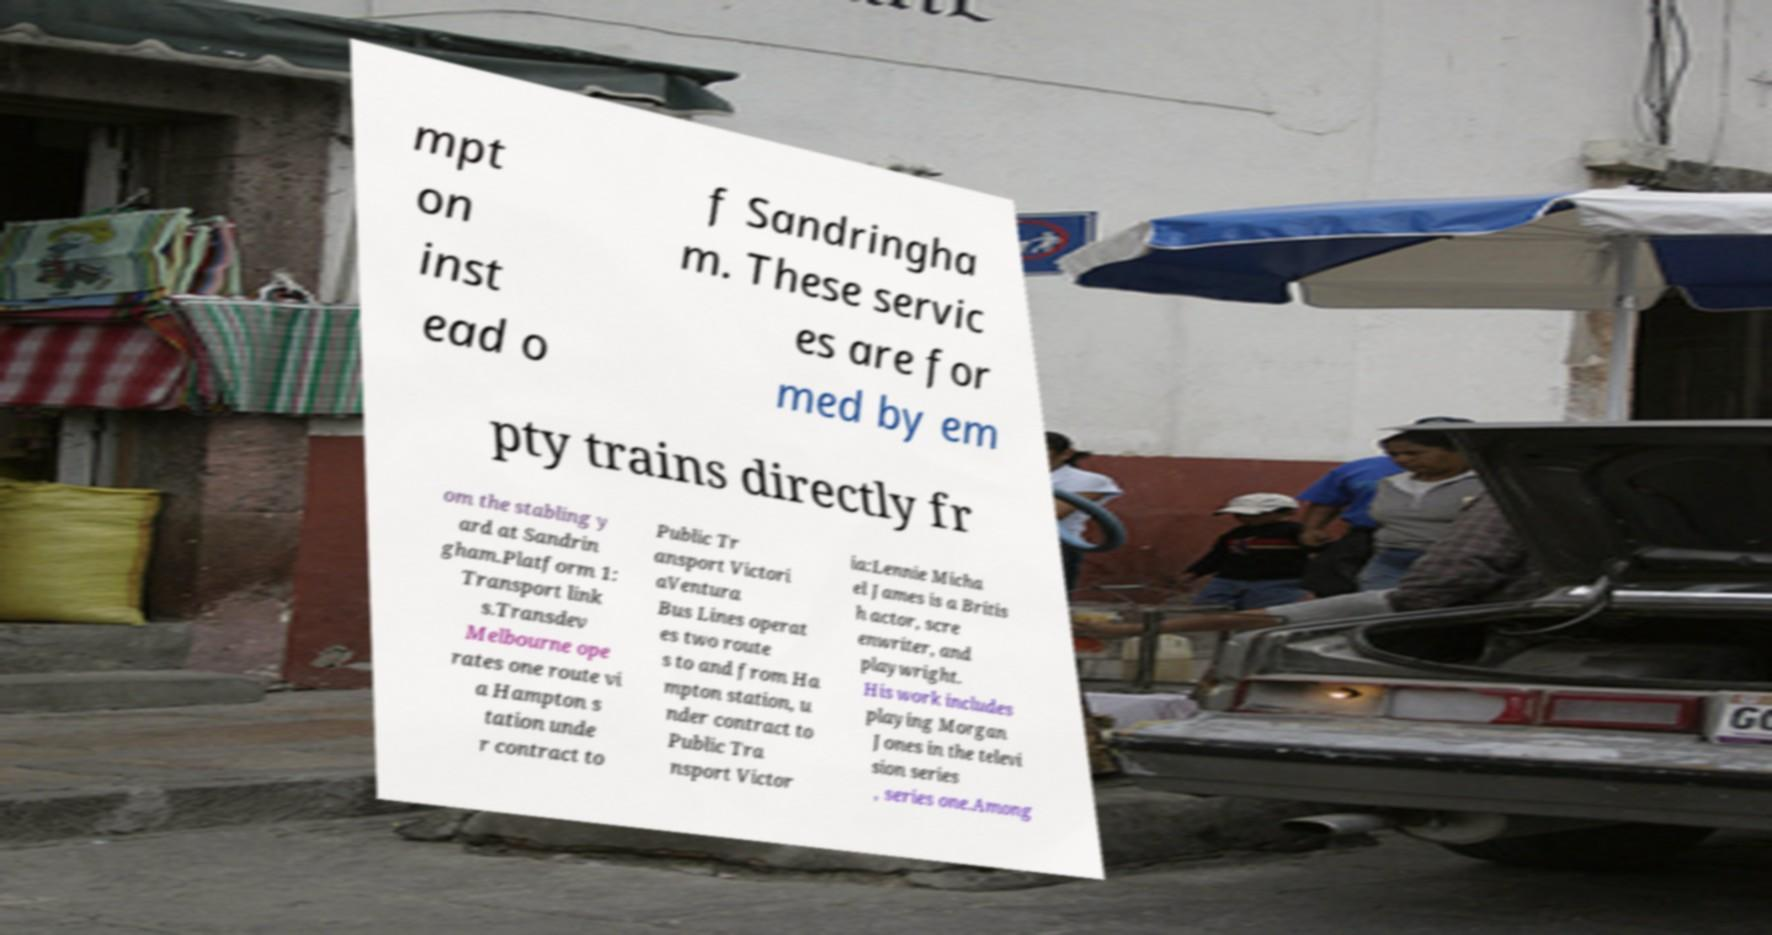What messages or text are displayed in this image? I need them in a readable, typed format. mpt on inst ead o f Sandringha m. These servic es are for med by em pty trains directly fr om the stabling y ard at Sandrin gham.Platform 1: Transport link s.Transdev Melbourne ope rates one route vi a Hampton s tation unde r contract to Public Tr ansport Victori aVentura Bus Lines operat es two route s to and from Ha mpton station, u nder contract to Public Tra nsport Victor ia:Lennie Micha el James is a Britis h actor, scre enwriter, and playwright. His work includes playing Morgan Jones in the televi sion series , series one.Among 